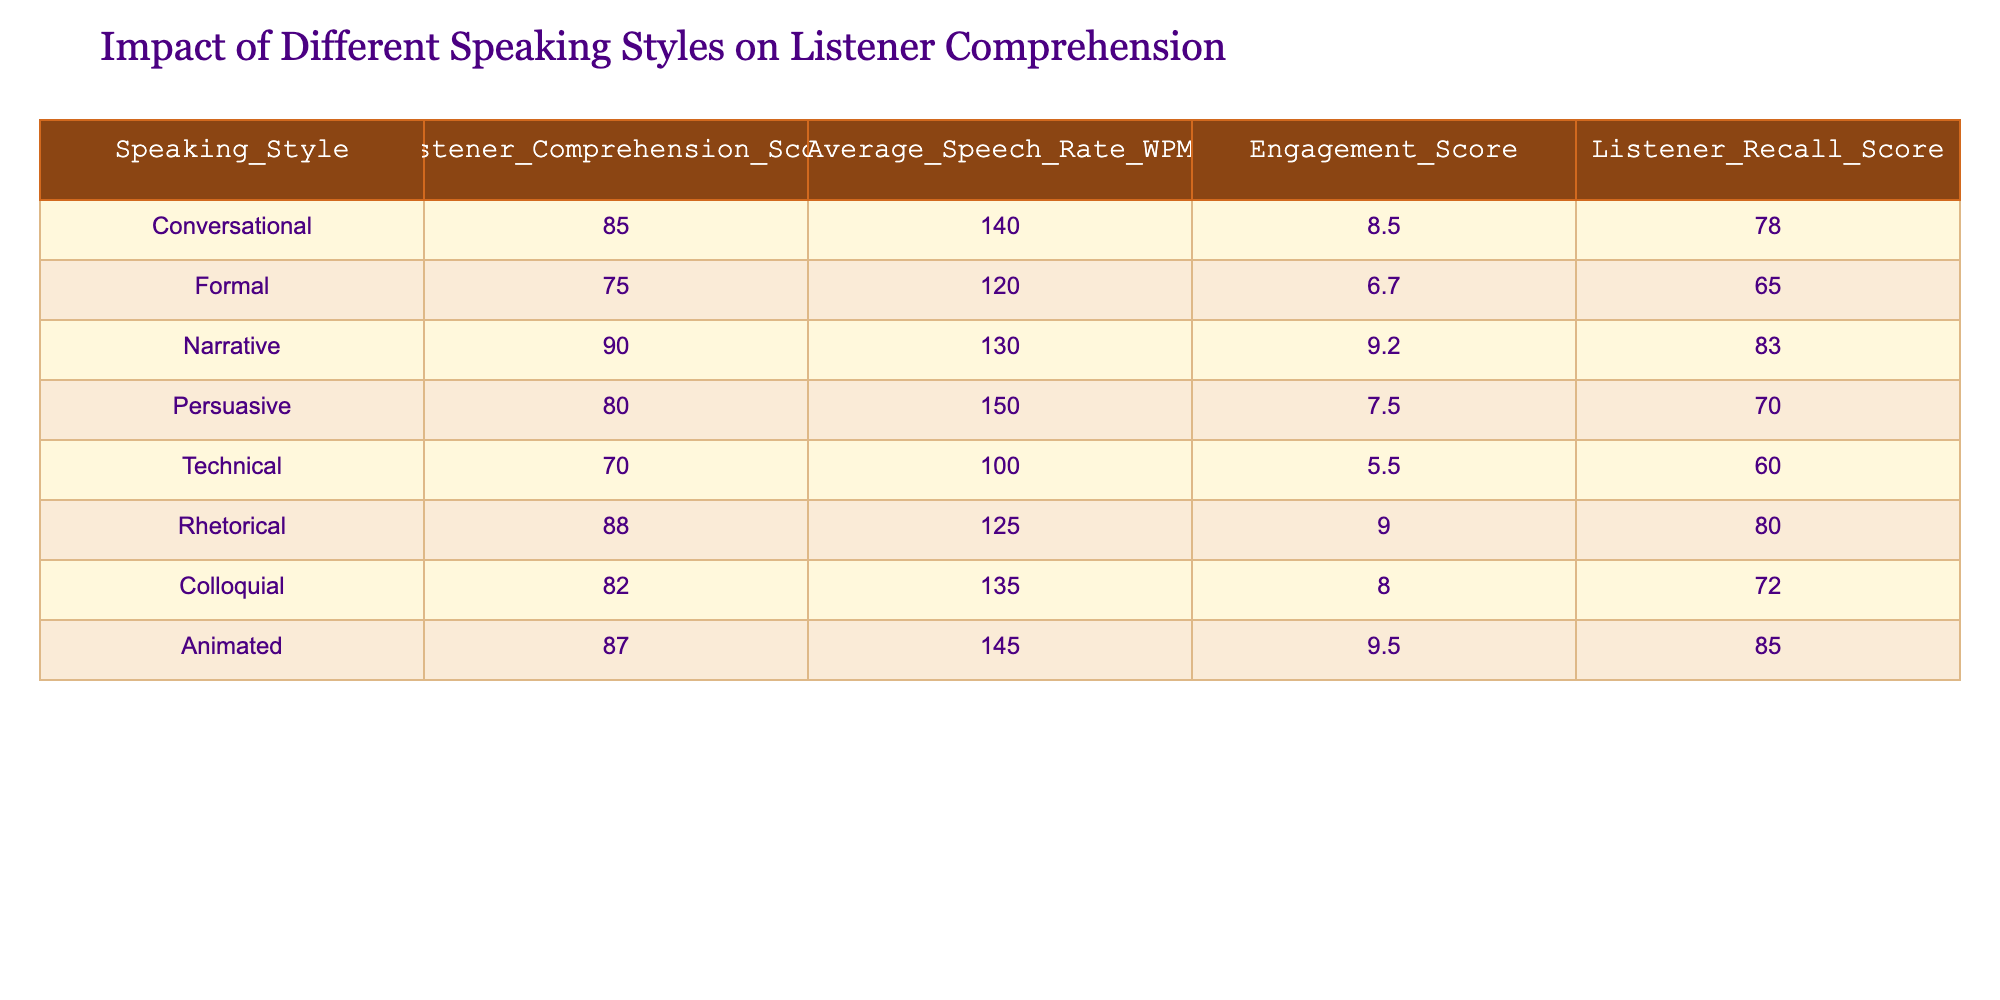What is the Listener Comprehension Score for the Narrative speaking style? The table presents the Listener Comprehension Score for each speaking style. The score for the Narrative style is given in the respective row.
Answer: 90 Which speaking style has the lowest Average Speech Rate in WPM? By comparing the Average Speech Rate for each speaking style, we see that the Technical style has the lowest value of 100 WPM.
Answer: Technical What is the difference in Listener Recall Score between the Animation and Colloquial speaking styles? The Listener Recall Score for Animated is 85, and for Colloquial, it is 72. The difference would be 85 - 72 = 13.
Answer: 13 Is the Engagement Score for Rhetorical higher than that for Persuasive speaking style? The Engagement Score for Rhetorical is 9.0, while for Persuasive it is 7.5. Since 9.0 is greater than 7.5, the statement is true.
Answer: Yes Which speaking style has both a high Listener Comprehension Score and a high Engagement Score? We look for speaking styles with both scores above average. The highest Listener Comprehension Score is 90 (Narrative) and has an Engagement Score of 9.2, which is also high.
Answer: Narrative What is the average Listener Recall Score across all speaking styles? We sum all the Listener Recall Scores: 78 + 65 + 83 + 70 + 60 + 80 + 72 + 85 = 593. Since there are 8 styles, we divide this total by 8. Thus, the average Recall Score is 593 / 8 = 74.125.
Answer: 74.125 Is there any speaking style that has an Engagement Score of 10 or higher? Checking the Engagement Scores, the maximum found is 9.5 for Animated. Therefore, no style reaches 10.
Answer: No Which speaking style has the highest combination of Listener Comprehension Score and Engagement Score? We assess the sum of the Listener Comprehension and Engagement Scores for each style. The Animated style has the sum 87 + 9.5 = 96.5, meaning it has the highest combined score.
Answer: Animated 